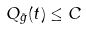<formula> <loc_0><loc_0><loc_500><loc_500>Q _ { \tilde { g } } ( t ) \leq C</formula> 